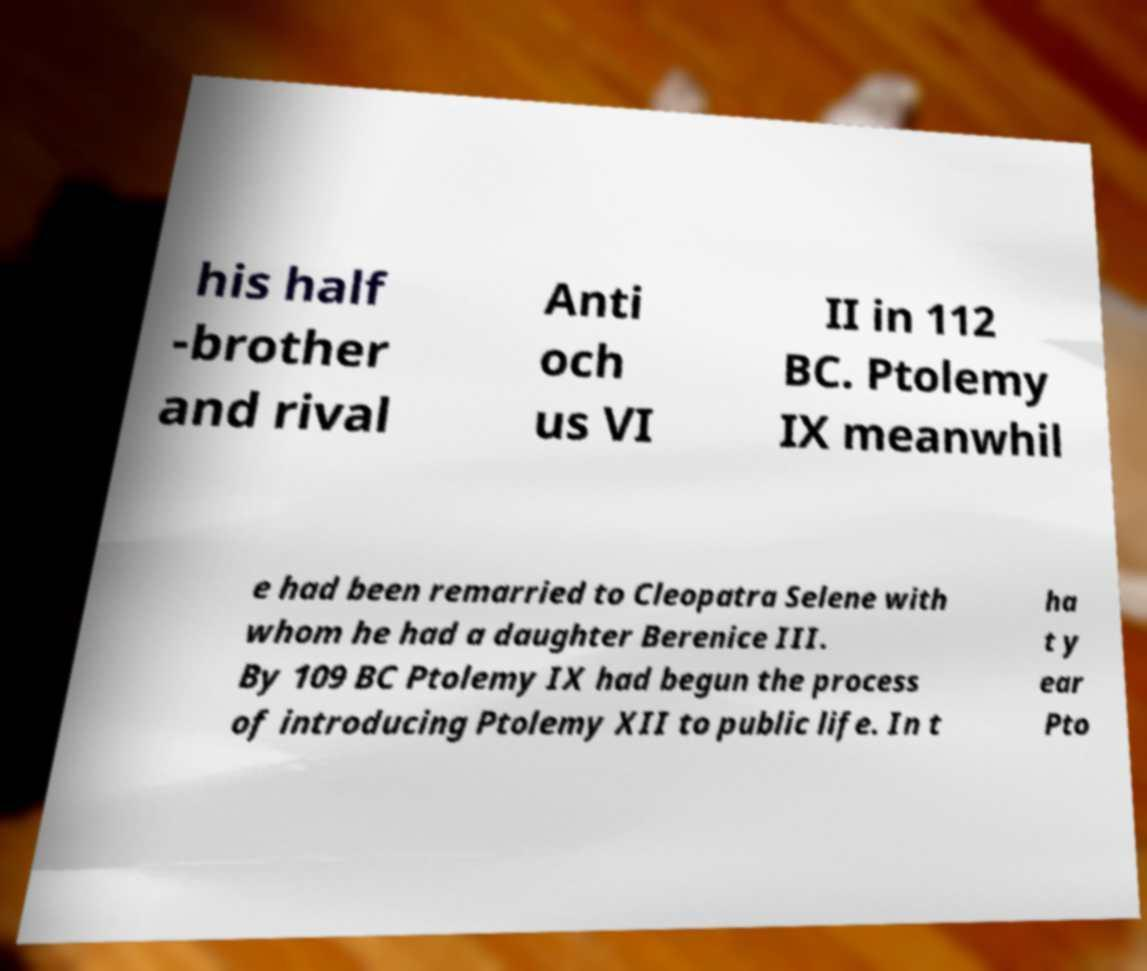Please read and relay the text visible in this image. What does it say? his half -brother and rival Anti och us VI II in 112 BC. Ptolemy IX meanwhil e had been remarried to Cleopatra Selene with whom he had a daughter Berenice III. By 109 BC Ptolemy IX had begun the process of introducing Ptolemy XII to public life. In t ha t y ear Pto 